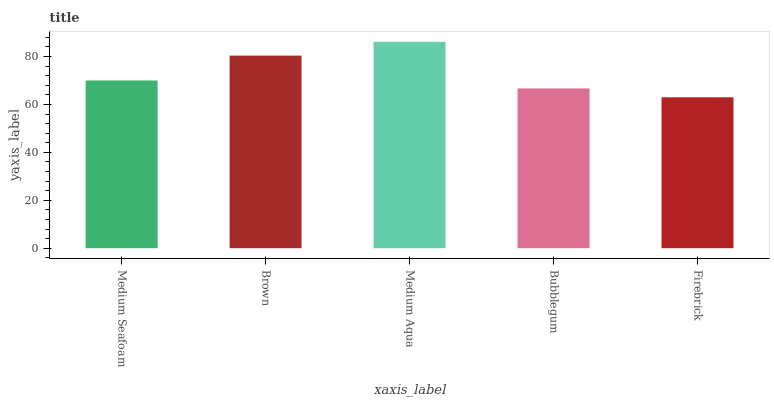Is Firebrick the minimum?
Answer yes or no. Yes. Is Medium Aqua the maximum?
Answer yes or no. Yes. Is Brown the minimum?
Answer yes or no. No. Is Brown the maximum?
Answer yes or no. No. Is Brown greater than Medium Seafoam?
Answer yes or no. Yes. Is Medium Seafoam less than Brown?
Answer yes or no. Yes. Is Medium Seafoam greater than Brown?
Answer yes or no. No. Is Brown less than Medium Seafoam?
Answer yes or no. No. Is Medium Seafoam the high median?
Answer yes or no. Yes. Is Medium Seafoam the low median?
Answer yes or no. Yes. Is Brown the high median?
Answer yes or no. No. Is Firebrick the low median?
Answer yes or no. No. 